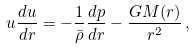Convert formula to latex. <formula><loc_0><loc_0><loc_500><loc_500>u \frac { d u } { d r } = - \frac { 1 } { \bar { \rho } } \frac { d p } { d r } - \frac { G M ( r ) } { r ^ { 2 } } \, ,</formula> 